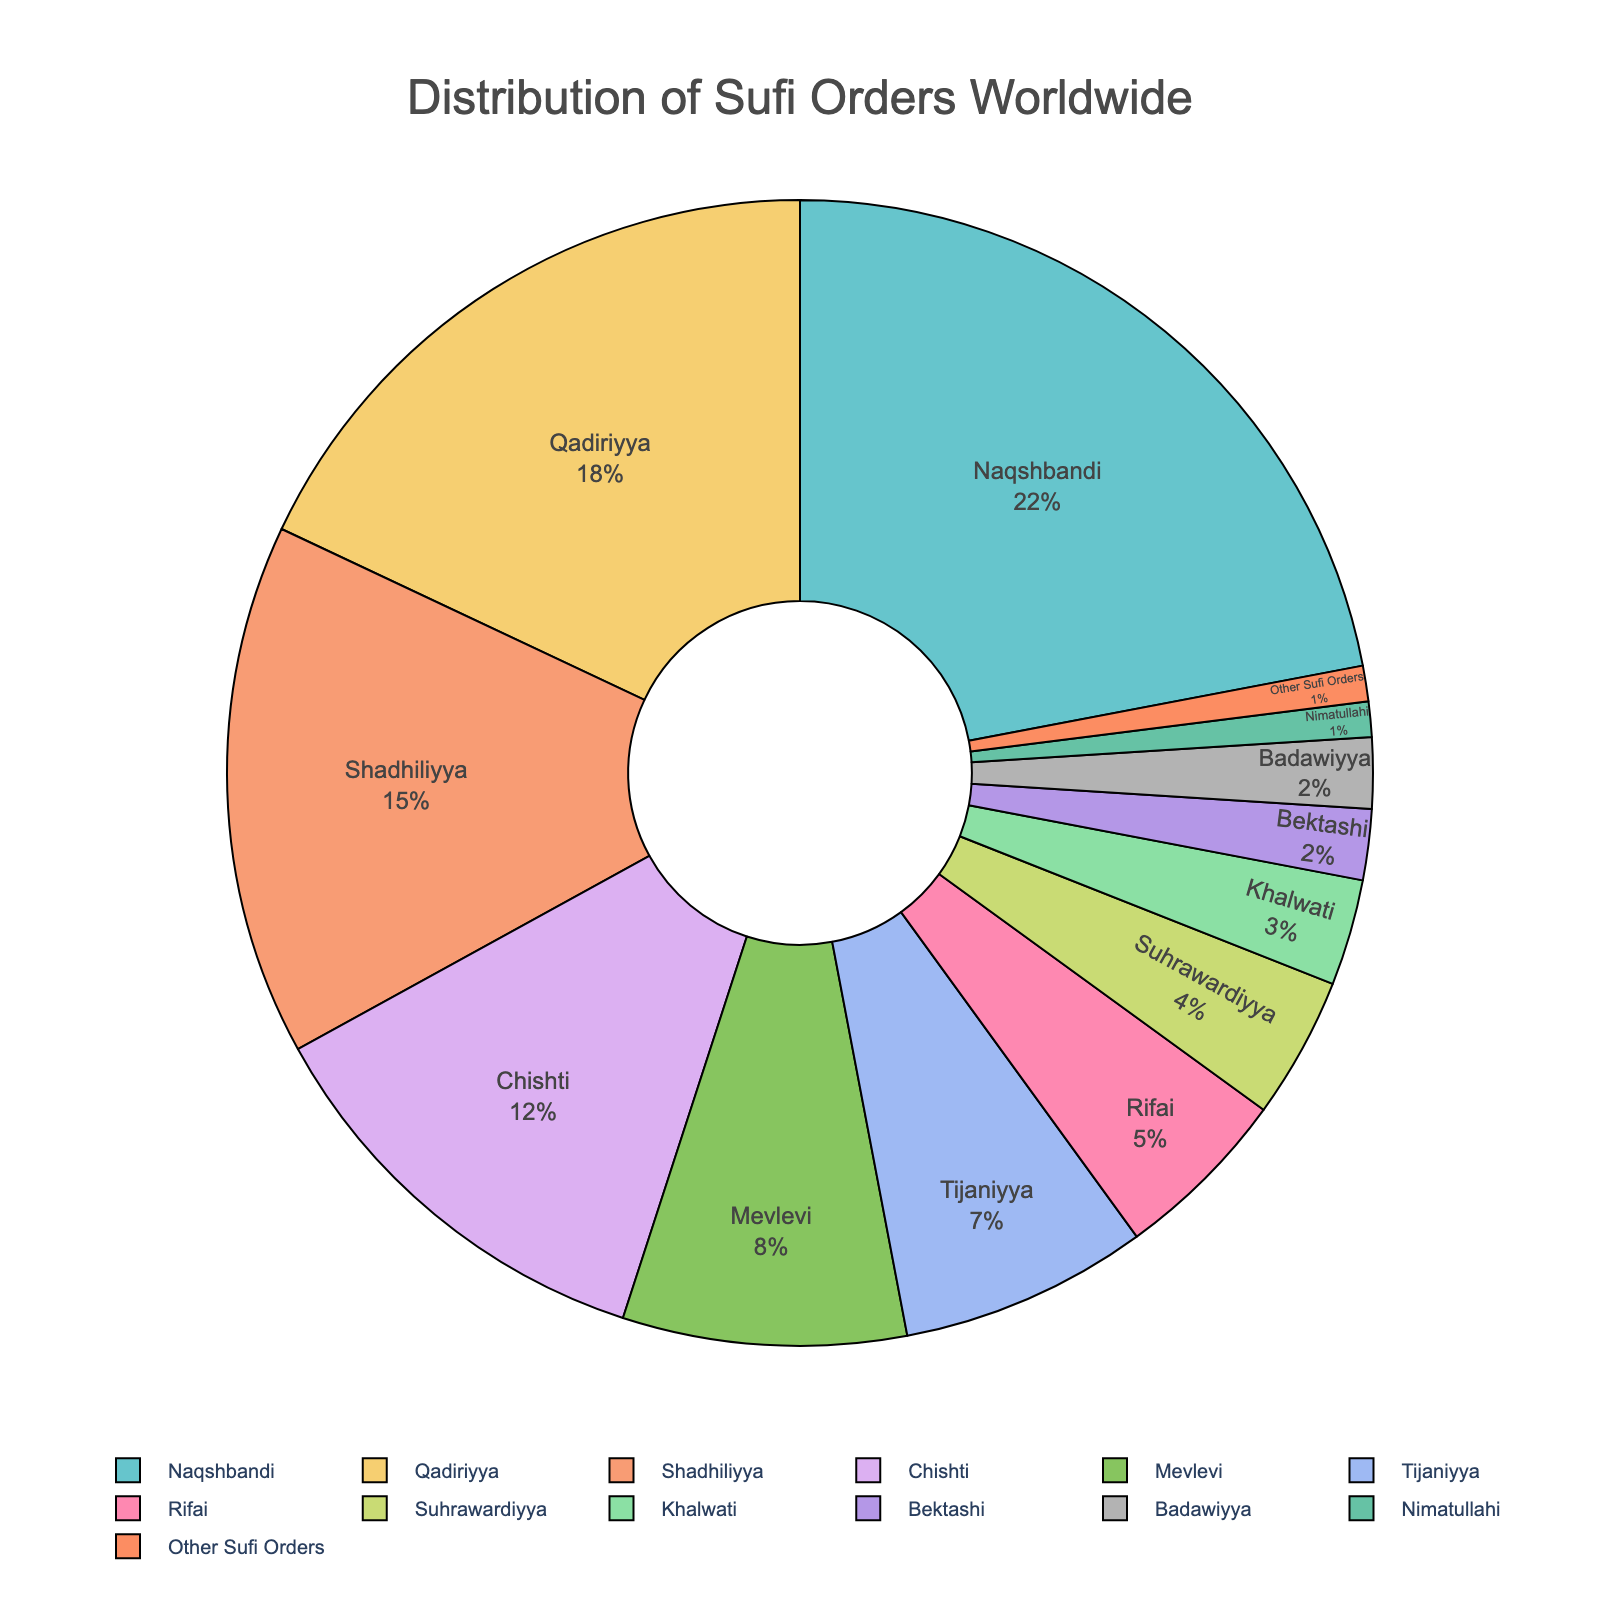Which Sufi order has the largest percentage of followers worldwide? The largest percentage can be determined by looking at the order with the biggest slice in the pie chart. Naqshbandi has the largest percentage.
Answer: Naqshbandi What is the cumulative percentage of followers of Naqshbandi, Qadiriyya, and Shadhiliyya orders? Add the percentages of Naqshbandi (22%), Qadiriyya (18%), and Shadhiliyya (15%). The sum is 22 + 18 + 15 = 55%.
Answer: 55% Which Sufi order has a higher percentage, Mevlevi or Chishti? Compare the percentages of Mevlevi (8%) and Chishti (12%). Chishti has a higher percentage.
Answer: Chishti How much larger is the percentage of Qadiriyya followers compared to Suhrawardiyya followers? Subtract the percentage of Suhrawardiyya (4%) from Qadiriyya (18%). The difference is 18 - 4 = 14%.
Answer: 14% What is the combined percentage of the orders that have less than 5% followers each? Sum the percentages of Rifai (5%), Suhrawardiyya (4%), Khalwati (3%), Bektashi (2%), Badawiyya (2%), Nimatullahi (1%), and Other Sufi Orders (1%). The total is 5 + 4 + 3 + 2 + 2 + 1 + 1 = 18%.
Answer: 18% Is the percentage of Tijaniyya followers greater than the combined percentage of Khalwati and Nimatullahi followers? The percentage of Tijaniyya (7%) should be compared with the sum of Khalwati (3%) and Nimatullahi (1%). 3 + 1 = 4%, and 7% is greater than 4%.
Answer: Yes Which Sufi order represents the smallest sliver in the pie chart? The smallest percentage can be identified by looking at the orders with the least representation. Nimatullahi and Other Sufi Orders both have the smallest slice at 1% each.
Answer: Nimatullahi and Other Sufi Orders By how much does the cumulative percentage of Chishti and Mevlevi exceed the percentage of Naqshbandi? Sum the percentages of Chishti (12%) and Mevlevi (8%), which equals 12 + 8 = 20%. Subtract Naqshbandi's percentage (22%) from this sum. 20% - 22% = -2%. However, the question asks for the excess, meaning 22% - 20% = 2%.
Answer: 2% If you were to group Rifai, Suhrawardiyya, and Khalwati together, what percentage of followers do they collectively represent? Add the percentages of Rifai (5%), Suhrawardiyya (4%), and Khalwati (3%). The total is 5 + 4 + 3 = 12%.
Answer: 12% Between Bektashi and Badawiyya, which order has a greater percentage, and by how much? Compare the percentages of Bektashi (2%) and Badawiyya (2%). They are equal, so the difference is 0%.
Answer: They are equal, difference is 0% 